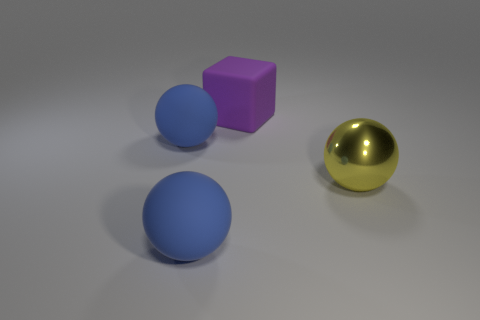Are there any other things that are the same shape as the metallic thing?
Offer a very short reply. Yes. What material is the big ball to the right of the big block?
Offer a very short reply. Metal. Are there any other things that are the same size as the purple matte thing?
Provide a succinct answer. Yes. There is a large purple block; are there any big balls behind it?
Give a very brief answer. No. There is a big shiny object; what shape is it?
Your answer should be compact. Sphere. How many things are either large objects right of the rubber cube or metal objects?
Ensure brevity in your answer.  1. What number of other objects are the same color as the large metal sphere?
Make the answer very short. 0. Do the shiny thing and the big matte sphere that is behind the big metal ball have the same color?
Provide a succinct answer. No. Does the yellow object have the same material as the blue ball that is behind the large metallic sphere?
Your answer should be very brief. No. What color is the large block?
Make the answer very short. Purple. 